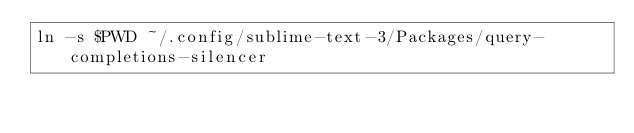<code> <loc_0><loc_0><loc_500><loc_500><_Bash_>ln -s $PWD ~/.config/sublime-text-3/Packages/query-completions-silencer
</code> 